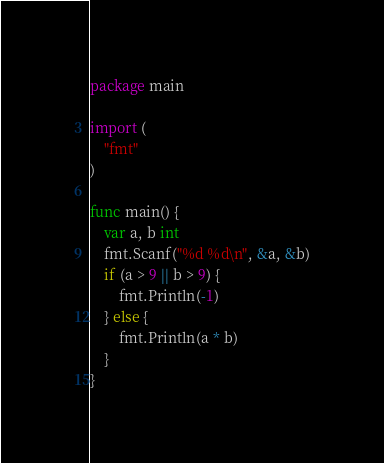<code> <loc_0><loc_0><loc_500><loc_500><_Go_>package main

import (
	"fmt"
)

func main() {
	var a, b int
	fmt.Scanf("%d %d\n", &a, &b)
	if (a > 9 || b > 9) {
		fmt.Println(-1)
	} else {
		fmt.Println(a * b)
	}
}</code> 